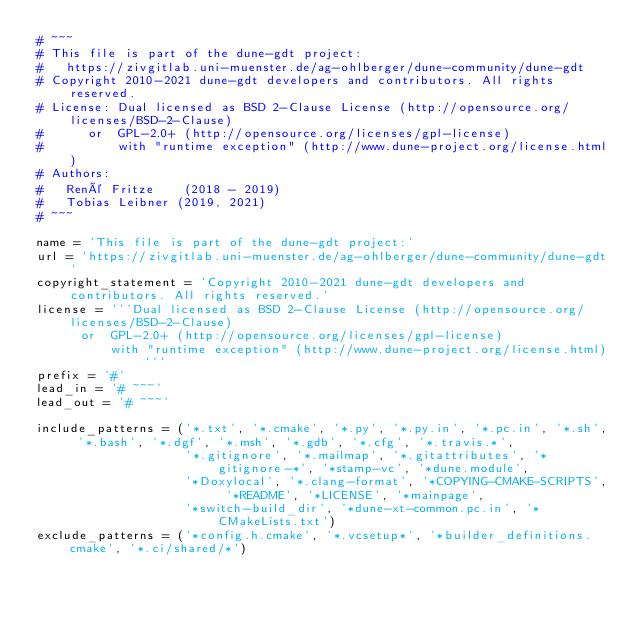<code> <loc_0><loc_0><loc_500><loc_500><_Python_># ~~~
# This file is part of the dune-gdt project:
#   https://zivgitlab.uni-muenster.de/ag-ohlberger/dune-community/dune-gdt
# Copyright 2010-2021 dune-gdt developers and contributors. All rights reserved.
# License: Dual licensed as BSD 2-Clause License (http://opensource.org/licenses/BSD-2-Clause)
#      or  GPL-2.0+ (http://opensource.org/licenses/gpl-license)
#          with "runtime exception" (http://www.dune-project.org/license.html)
# Authors:
#   René Fritze    (2018 - 2019)
#   Tobias Leibner (2019, 2021)
# ~~~

name = 'This file is part of the dune-gdt project:'
url = 'https://zivgitlab.uni-muenster.de/ag-ohlberger/dune-community/dune-gdt'
copyright_statement = 'Copyright 2010-2021 dune-gdt developers and contributors. All rights reserved.'
license = '''Dual licensed as BSD 2-Clause License (http://opensource.org/licenses/BSD-2-Clause)
      or  GPL-2.0+ (http://opensource.org/licenses/gpl-license)
          with "runtime exception" (http://www.dune-project.org/license.html)'''
prefix = '#'
lead_in = '# ~~~'
lead_out = '# ~~~'

include_patterns = ('*.txt', '*.cmake', '*.py', '*.py.in', '*.pc.in', '*.sh', '*.bash', '*.dgf', '*.msh', '*.gdb', '*.cfg', '*.travis.*',
                    '*.gitignore', '*.mailmap', '*.gitattributes', '*gitignore-*', '*stamp-vc', '*dune.module',
                    '*Doxylocal', '*.clang-format', '*COPYING-CMAKE-SCRIPTS', '*README', '*LICENSE', '*mainpage',
                    '*switch-build_dir', '*dune-xt-common.pc.in', '*CMakeLists.txt')
exclude_patterns = ('*config.h.cmake', '*.vcsetup*', '*builder_definitions.cmake', '*.ci/shared/*')
</code> 